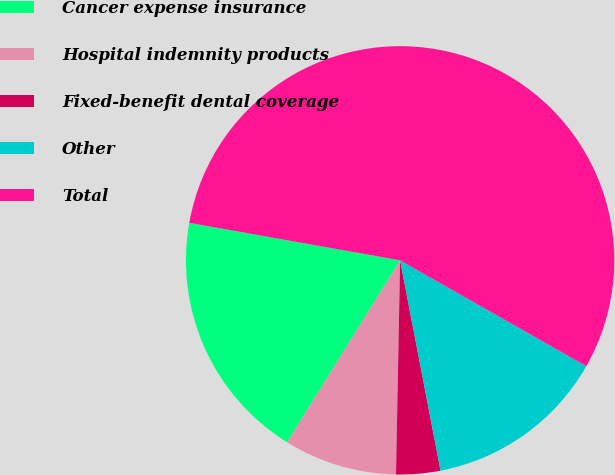Convert chart to OTSL. <chart><loc_0><loc_0><loc_500><loc_500><pie_chart><fcel>Cancer expense insurance<fcel>Hospital indemnity products<fcel>Fixed-benefit dental coverage<fcel>Other<fcel>Total<nl><fcel>18.96%<fcel>8.54%<fcel>3.33%<fcel>13.75%<fcel>55.43%<nl></chart> 